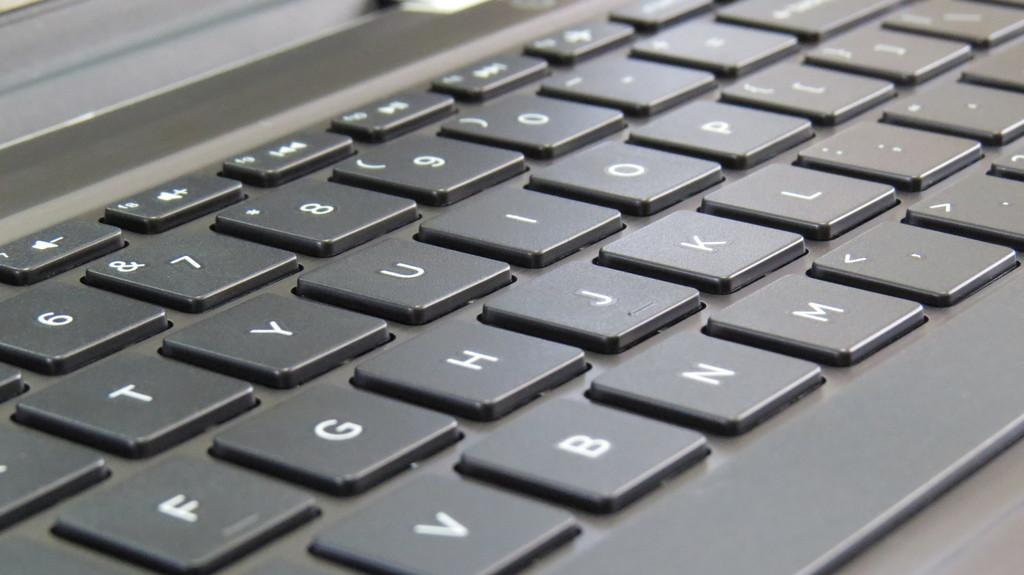Provide a one-sentence caption for the provided image. Black keyboard with white keys that has the number 6 on the top left. 